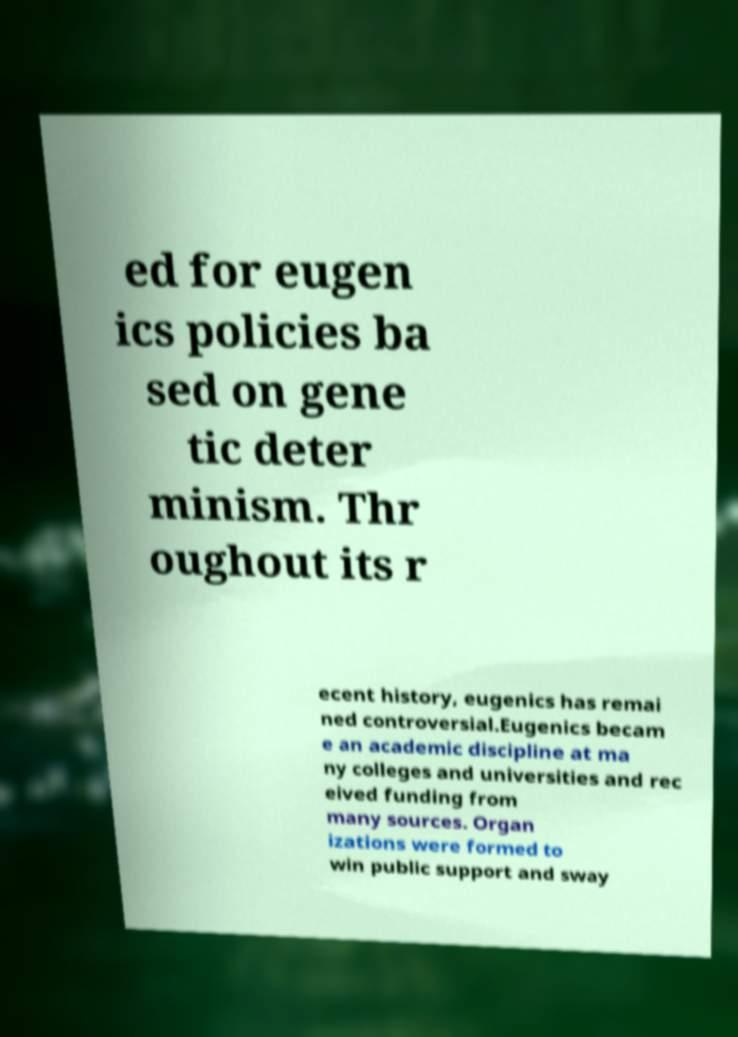There's text embedded in this image that I need extracted. Can you transcribe it verbatim? ed for eugen ics policies ba sed on gene tic deter minism. Thr oughout its r ecent history, eugenics has remai ned controversial.Eugenics becam e an academic discipline at ma ny colleges and universities and rec eived funding from many sources. Organ izations were formed to win public support and sway 